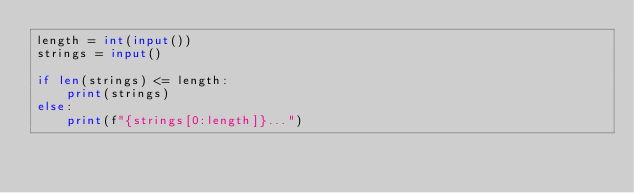Convert code to text. <code><loc_0><loc_0><loc_500><loc_500><_Python_>length = int(input())
strings = input()

if len(strings) <= length:
    print(strings)
else:
    print(f"{strings[0:length]}...")
</code> 